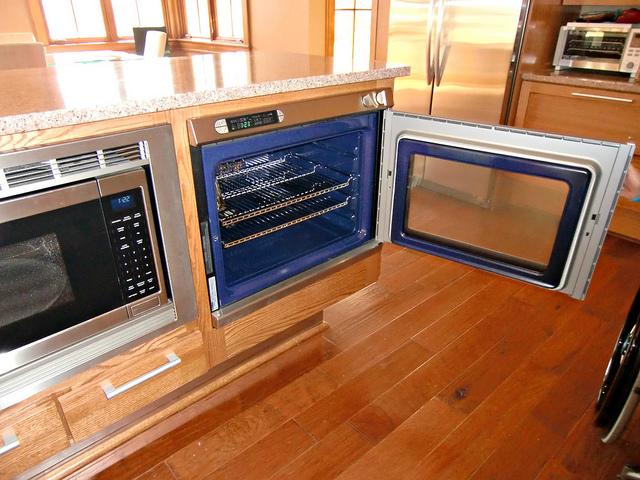What is the time on the microwave?
Concise answer only. 1:22. Is anyone cooking right now?
Concise answer only. No. What color is the oven?
Write a very short answer. Blue. 